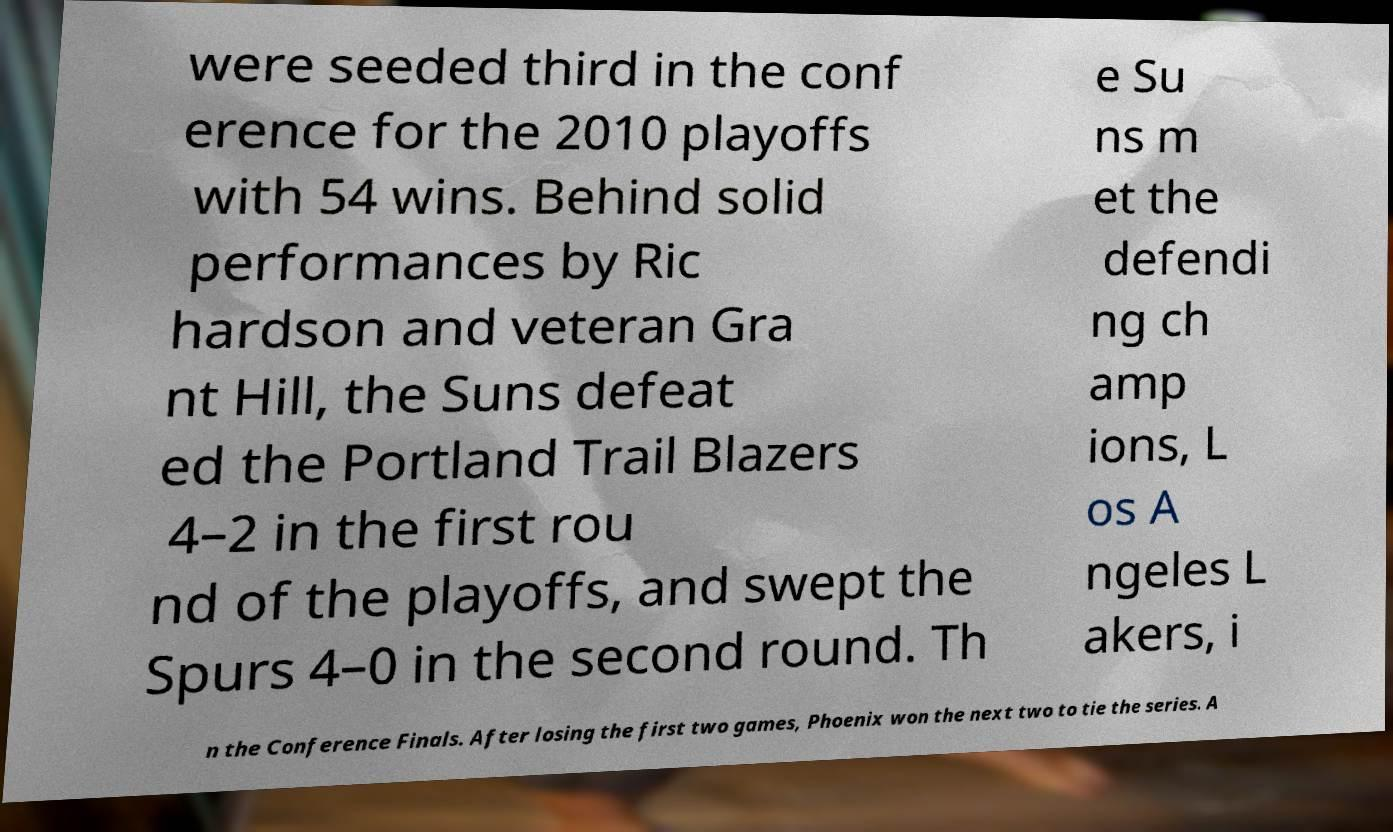There's text embedded in this image that I need extracted. Can you transcribe it verbatim? were seeded third in the conf erence for the 2010 playoffs with 54 wins. Behind solid performances by Ric hardson and veteran Gra nt Hill, the Suns defeat ed the Portland Trail Blazers 4–2 in the first rou nd of the playoffs, and swept the Spurs 4–0 in the second round. Th e Su ns m et the defendi ng ch amp ions, L os A ngeles L akers, i n the Conference Finals. After losing the first two games, Phoenix won the next two to tie the series. A 